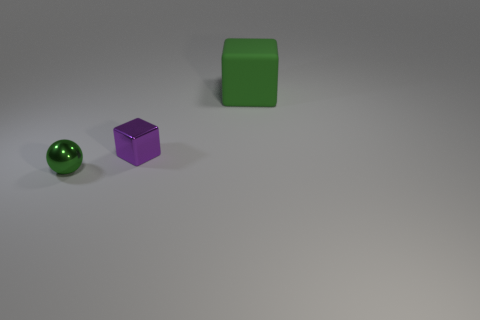Is the number of small gray blocks less than the number of metal spheres?
Provide a succinct answer. Yes. There is a shiny thing that is behind the metal sphere; does it have the same size as the green thing that is in front of the big green block?
Offer a terse response. Yes. Are there any purple spheres made of the same material as the large thing?
Keep it short and to the point. No. What number of things are either large things behind the small cube or big green things?
Give a very brief answer. 1. Is the material of the small object that is left of the tiny metallic cube the same as the tiny cube?
Ensure brevity in your answer.  Yes. Is the small purple metal object the same shape as the large green thing?
Keep it short and to the point. Yes. There is a cube that is on the right side of the purple metallic object; how many purple shiny blocks are in front of it?
Offer a terse response. 1. There is a large green thing that is the same shape as the purple metallic object; what is its material?
Your response must be concise. Rubber. Do the thing that is right of the metallic cube and the shiny ball have the same color?
Provide a succinct answer. Yes. Are the small sphere and the object that is to the right of the purple thing made of the same material?
Keep it short and to the point. No. 